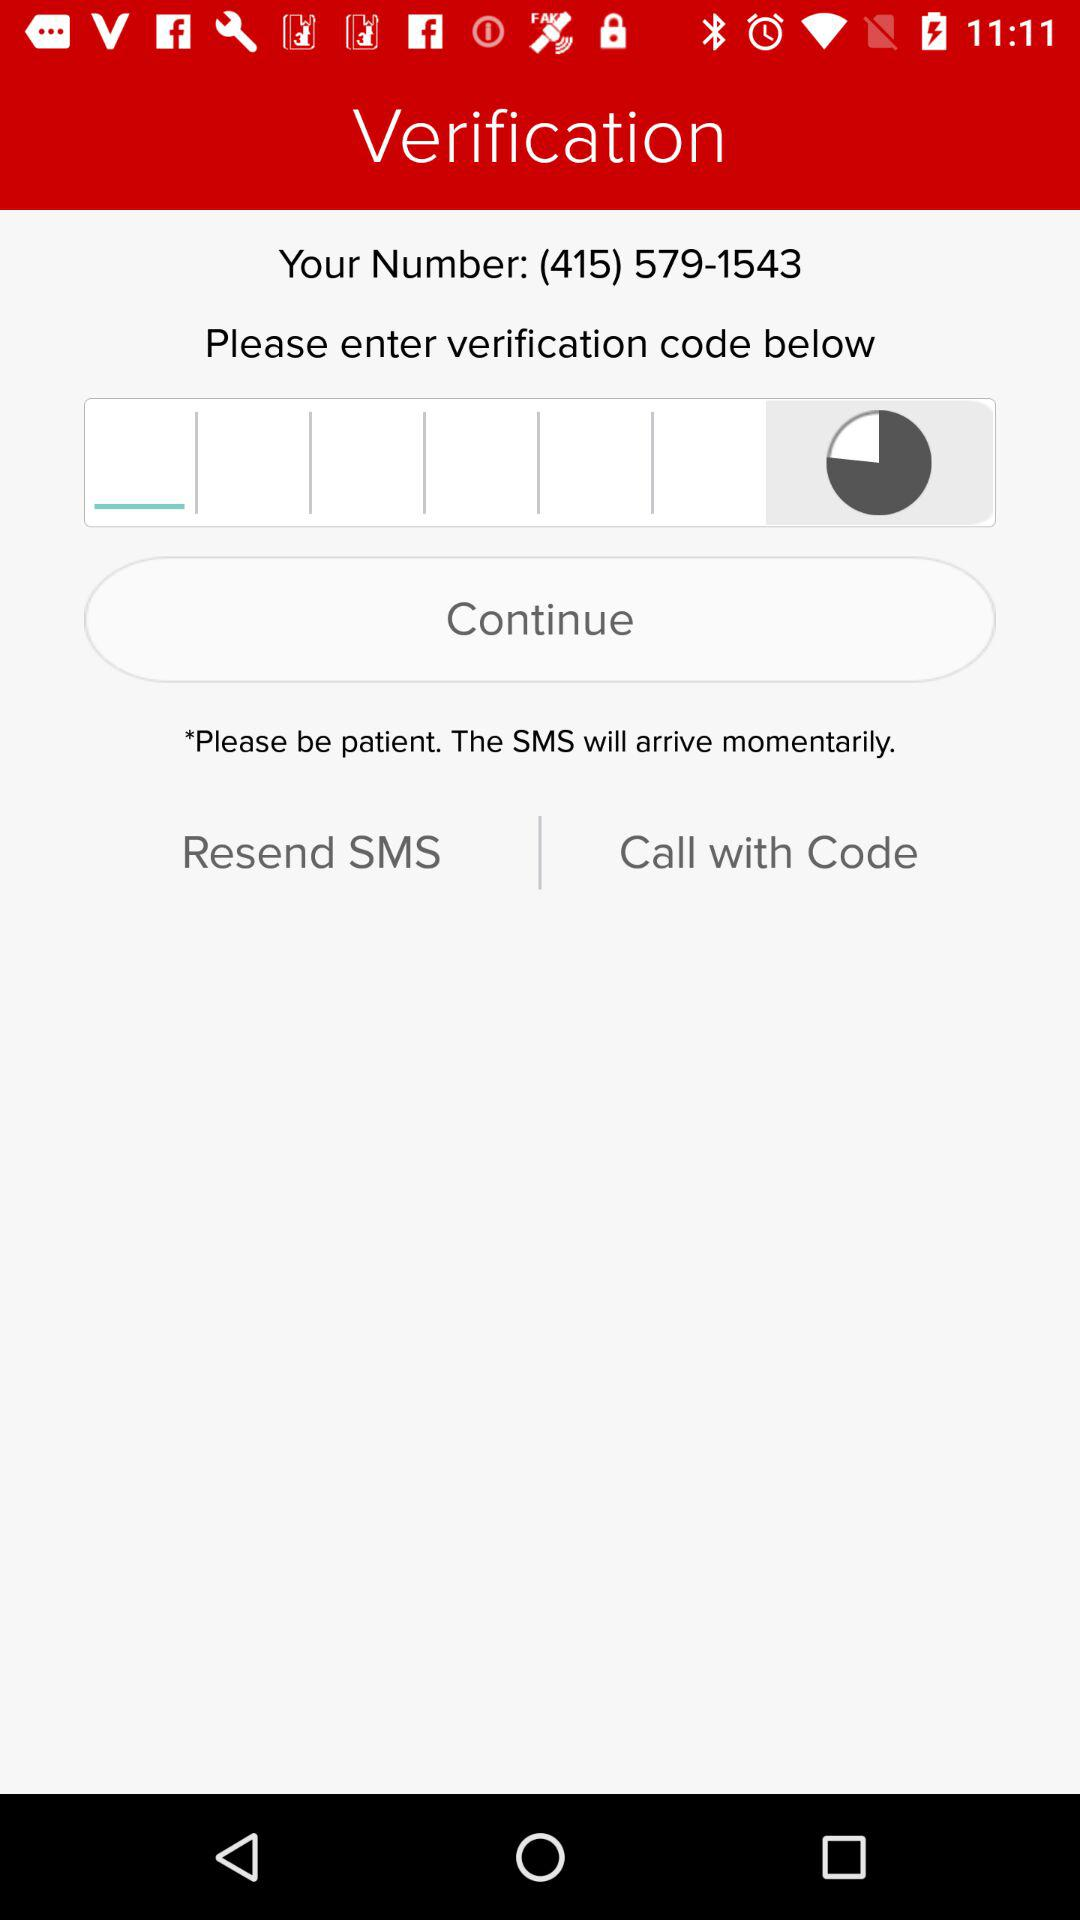What is the name of the application? The name of the application is "Boss Revolution". 